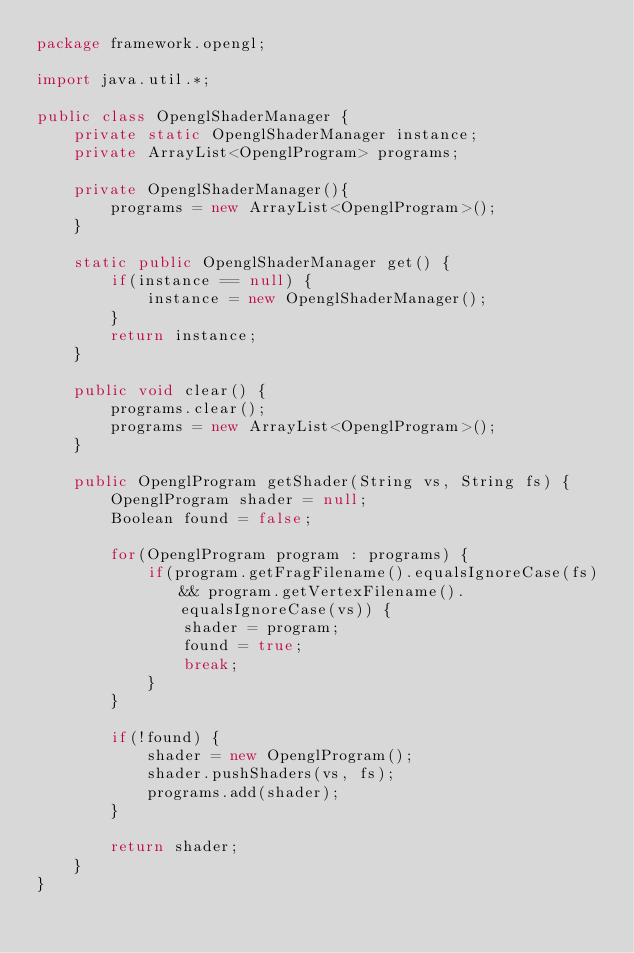Convert code to text. <code><loc_0><loc_0><loc_500><loc_500><_Java_>package framework.opengl;

import java.util.*;

public class OpenglShaderManager {
    private static OpenglShaderManager instance;
    private ArrayList<OpenglProgram> programs;

    private OpenglShaderManager(){
        programs = new ArrayList<OpenglProgram>();
    }

    static public OpenglShaderManager get() {
        if(instance == null) {
            instance = new OpenglShaderManager();
        }
        return instance;
    }

    public void clear() {
        programs.clear();
        programs = new ArrayList<OpenglProgram>();
    }

    public OpenglProgram getShader(String vs, String fs) {
        OpenglProgram shader = null;
        Boolean found = false;

        for(OpenglProgram program : programs) {
            if(program.getFragFilename().equalsIgnoreCase(fs) && program.getVertexFilename().equalsIgnoreCase(vs)) {
                shader = program;
                found = true;
                break;
            }
        }

        if(!found) {
            shader = new OpenglProgram();
            shader.pushShaders(vs, fs);
            programs.add(shader);
        }

        return shader;
    }
}
</code> 